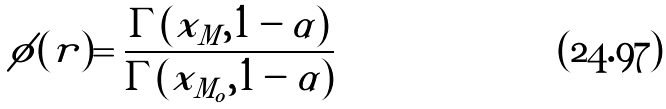Convert formula to latex. <formula><loc_0><loc_0><loc_500><loc_500>\phi ( r ) = \frac { \Gamma ( x _ { M } , 1 - \alpha ) } { \Gamma ( x _ { M _ { o } } , 1 - \alpha ) }</formula> 